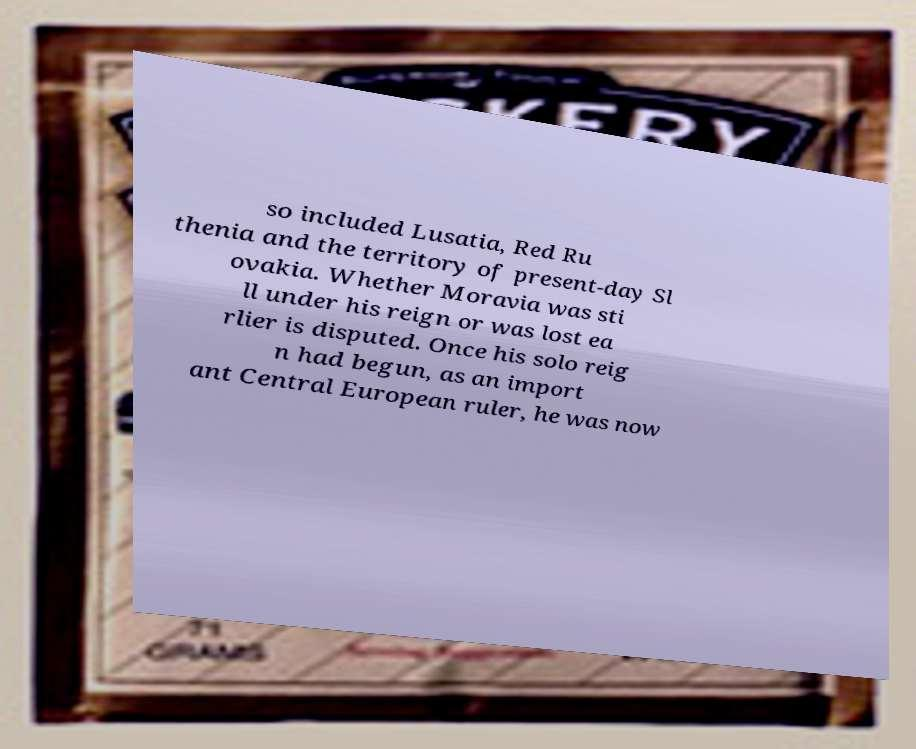Could you extract and type out the text from this image? so included Lusatia, Red Ru thenia and the territory of present-day Sl ovakia. Whether Moravia was sti ll under his reign or was lost ea rlier is disputed. Once his solo reig n had begun, as an import ant Central European ruler, he was now 